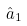<formula> <loc_0><loc_0><loc_500><loc_500>\hat { a } _ { 1 }</formula> 